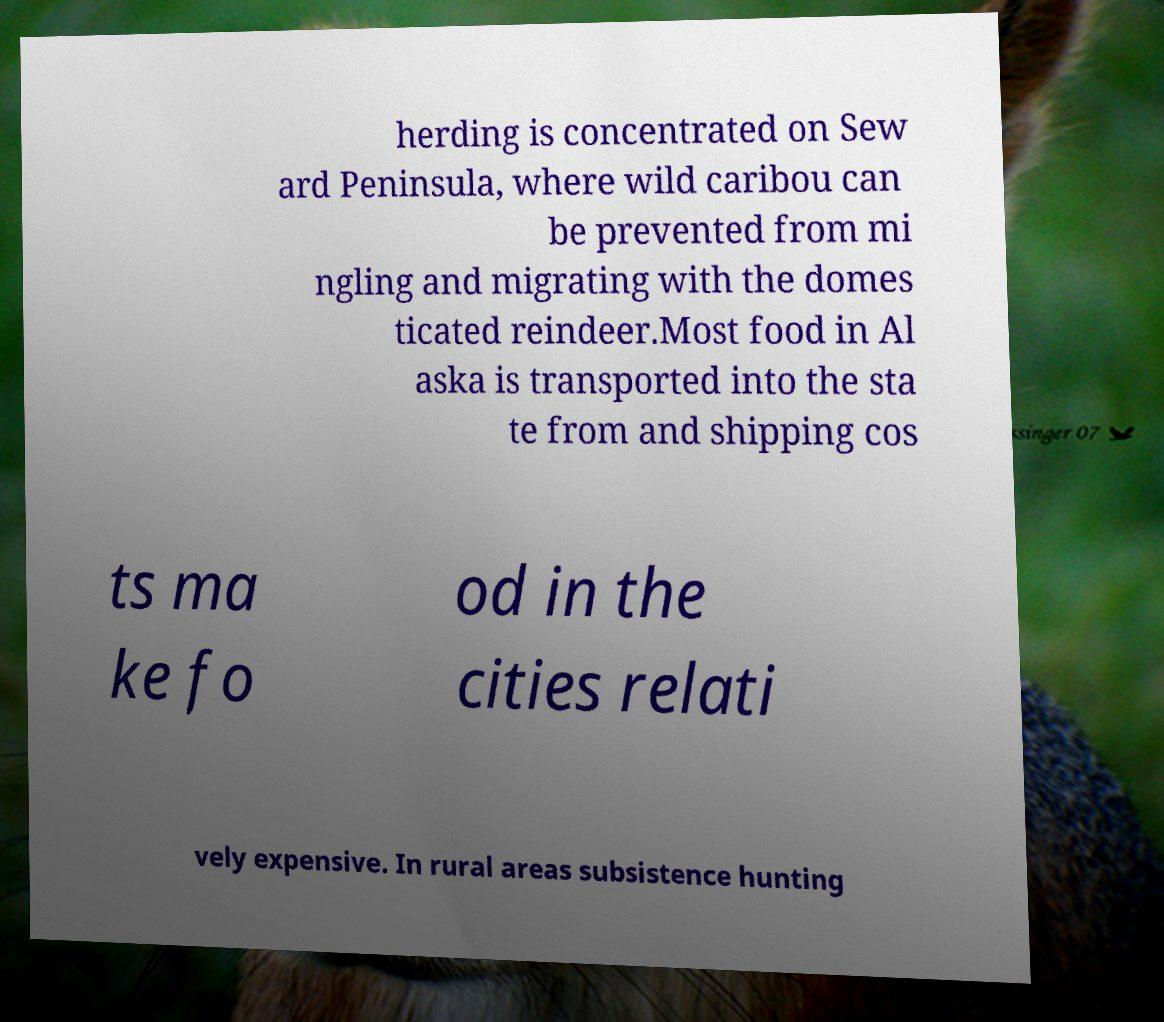Could you assist in decoding the text presented in this image and type it out clearly? herding is concentrated on Sew ard Peninsula, where wild caribou can be prevented from mi ngling and migrating with the domes ticated reindeer.Most food in Al aska is transported into the sta te from and shipping cos ts ma ke fo od in the cities relati vely expensive. In rural areas subsistence hunting 